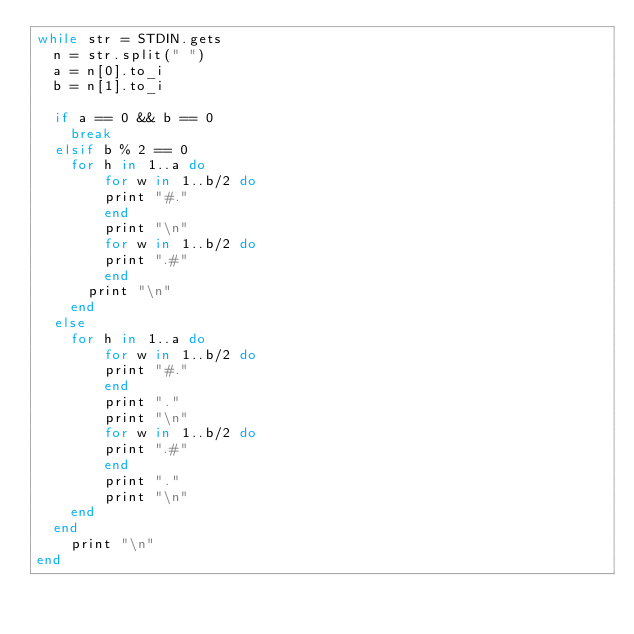Convert code to text. <code><loc_0><loc_0><loc_500><loc_500><_Ruby_>while str = STDIN.gets
  n = str.split(" ")
  a = n[0].to_i
  b = n[1].to_i

  if a == 0 && b == 0
    break
  elsif b % 2 == 0
    for h in 1..a do
        for w in 1..b/2 do
        print "#."
        end
        print "\n"
        for w in 1..b/2 do
        print ".#"
        end
      print "\n"
    end
  else
    for h in 1..a do
        for w in 1..b/2 do
        print "#."
        end
        print "."
        print "\n"
        for w in 1..b/2 do
        print ".#"
        end
        print "."
        print "\n"
    end
  end
    print "\n"
end
</code> 